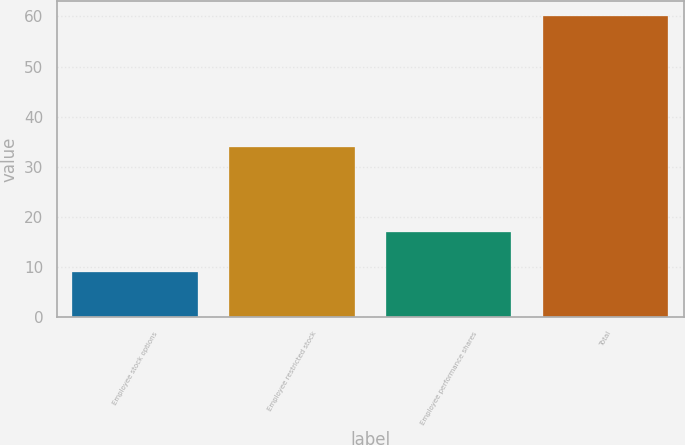<chart> <loc_0><loc_0><loc_500><loc_500><bar_chart><fcel>Employee stock options<fcel>Employee restricted stock<fcel>Employee performance shares<fcel>Total<nl><fcel>9<fcel>34<fcel>17<fcel>60<nl></chart> 